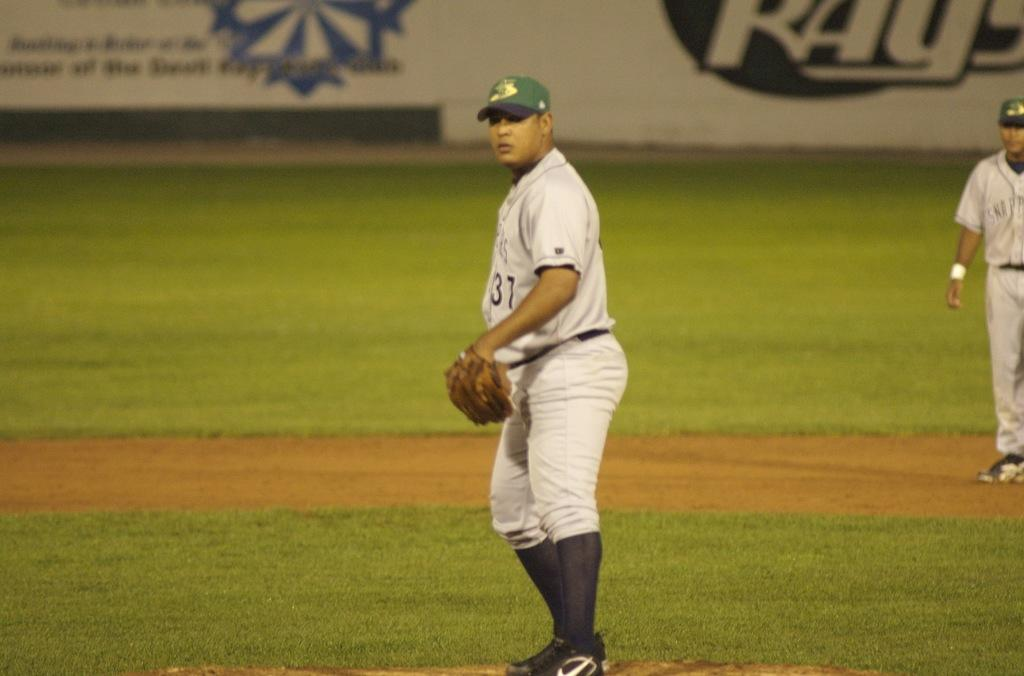Provide a one-sentence caption for the provided image. a baseball player wearing the number 31 jersey. 